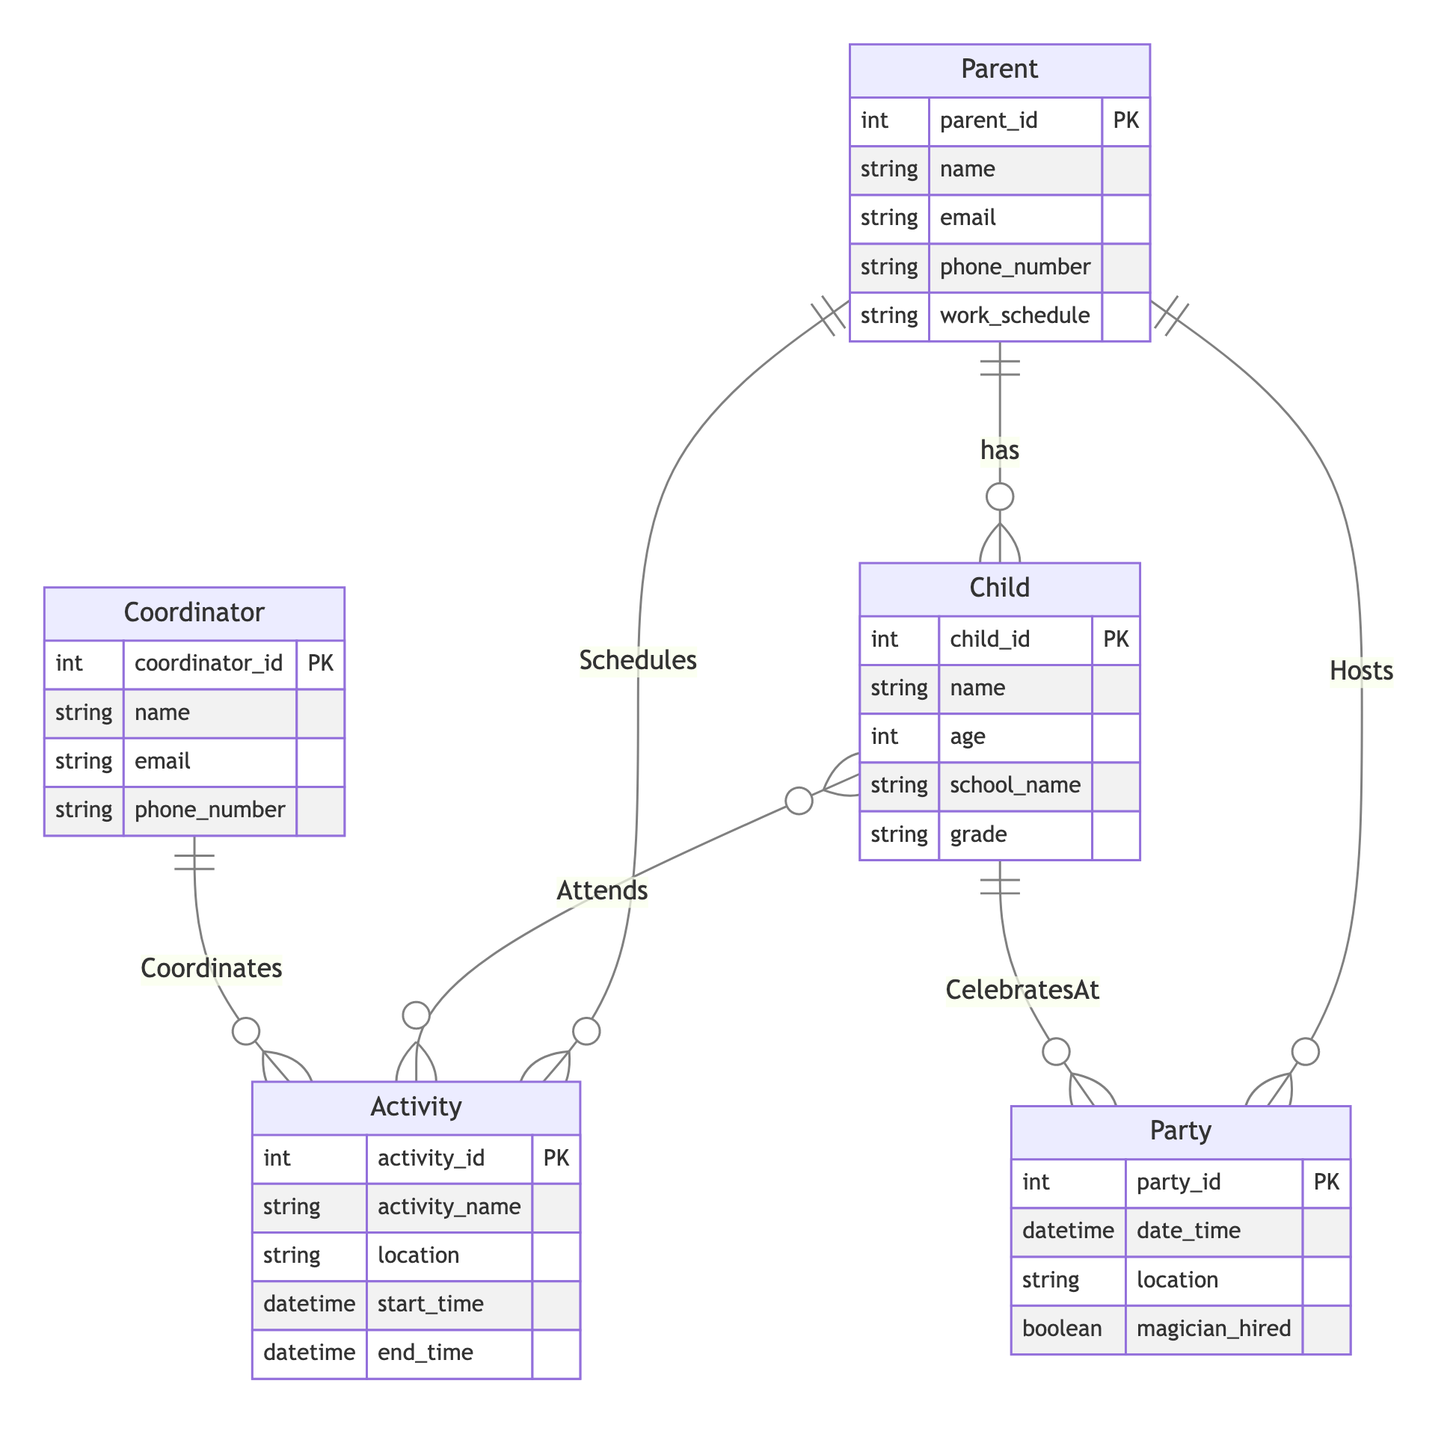what entities are included in the diagram? The diagram includes the entities Parent, Child, Activity, Coordinator, and Party.
Answer: Parent, Child, Activity, Coordinator, Party how many attributes does the Child entity have? The Child entity has five attributes: child_id, name, age, school_name, and grade.
Answer: five what is the relationship between Parent and Party? The Parent entity has a "Hosts" relationship with the Party entity, indicating that parents host parties.
Answer: Hosts how many relationships are there in the diagram? There are five relationships: Schedules, Attends, Coordinates, Hosts, and CelebratesAt.
Answer: five which entity is responsible for coordinating activities? The Coordinator entity is responsible for coordinating activities as indicated by the "Coordinates" relationship.
Answer: Coordinator who celebrates at the party from the Child entity? The relationship "CelebratesAt" indicates that the Child entity celebrates at the Party entity.
Answer: Child how many children can attend a single activity? Since the relationship "Attends" connects Child and Activity, multiple children can attend a single activity, thus there is no strict limit defined in the diagram.
Answer: unlimited which entity schedules activities for the children? The Parent entity schedules activities as shown by the "Schedules" relationship between Parent and Activity.
Answer: Parent what attribute indicates if a magician is hired for the party? The attribute "magician_hired" in the Party entity indicates if a magician is hired for the party.
Answer: magician_hired 